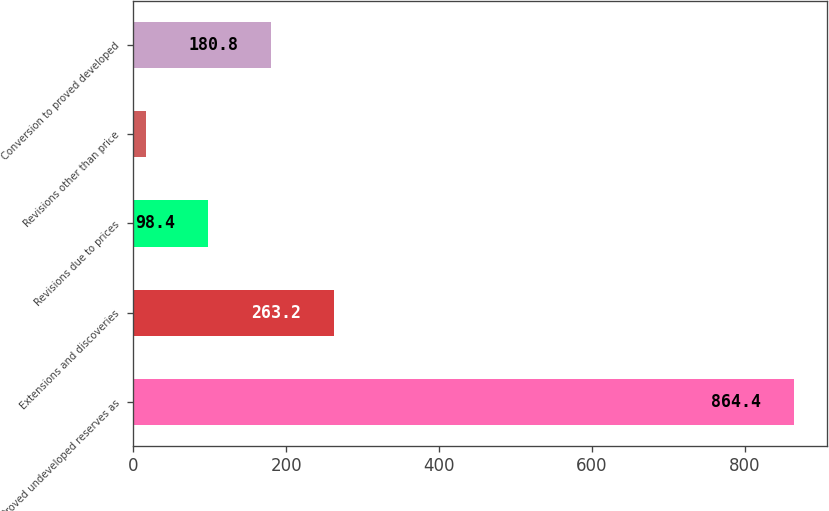<chart> <loc_0><loc_0><loc_500><loc_500><bar_chart><fcel>Proved undeveloped reserves as<fcel>Extensions and discoveries<fcel>Revisions due to prices<fcel>Revisions other than price<fcel>Conversion to proved developed<nl><fcel>864.4<fcel>263.2<fcel>98.4<fcel>16<fcel>180.8<nl></chart> 